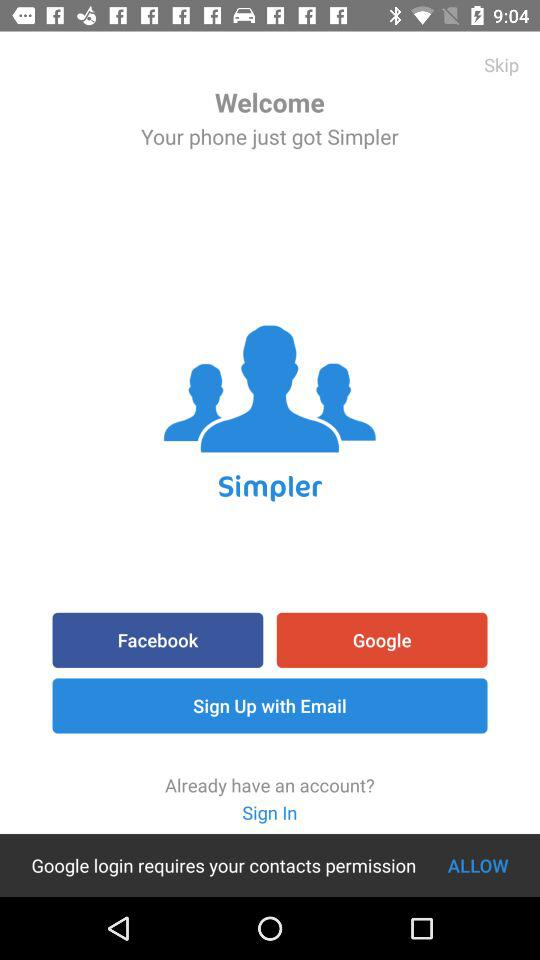Which accounts can be used to continue logging in? The accounts that can be used to continue logging in are "Facebook", "Google" and "Email". 